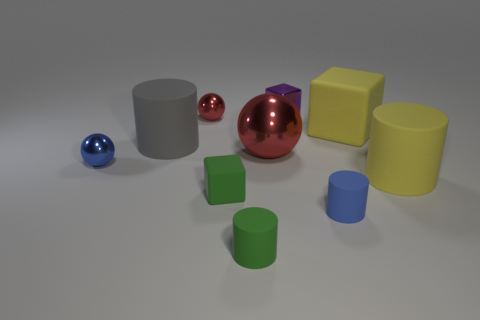There is a green object that is made of the same material as the green cylinder; what size is it?
Give a very brief answer. Small. How big is the green cylinder?
Make the answer very short. Small. What material is the green block?
Make the answer very short. Rubber. Do the cube on the right side of the metallic cube and the small red metal sphere have the same size?
Keep it short and to the point. No. What number of objects are yellow objects or large yellow rubber blocks?
Your answer should be very brief. 2. The small thing that is the same color as the large ball is what shape?
Give a very brief answer. Sphere. There is a shiny thing that is behind the big shiny thing and on the left side of the tiny purple thing; what size is it?
Your answer should be very brief. Small. What number of small metal cubes are there?
Keep it short and to the point. 1. How many cubes are green objects or red things?
Your answer should be very brief. 1. What number of tiny matte cylinders are behind the big cylinder that is in front of the tiny ball that is in front of the gray object?
Provide a succinct answer. 0. 